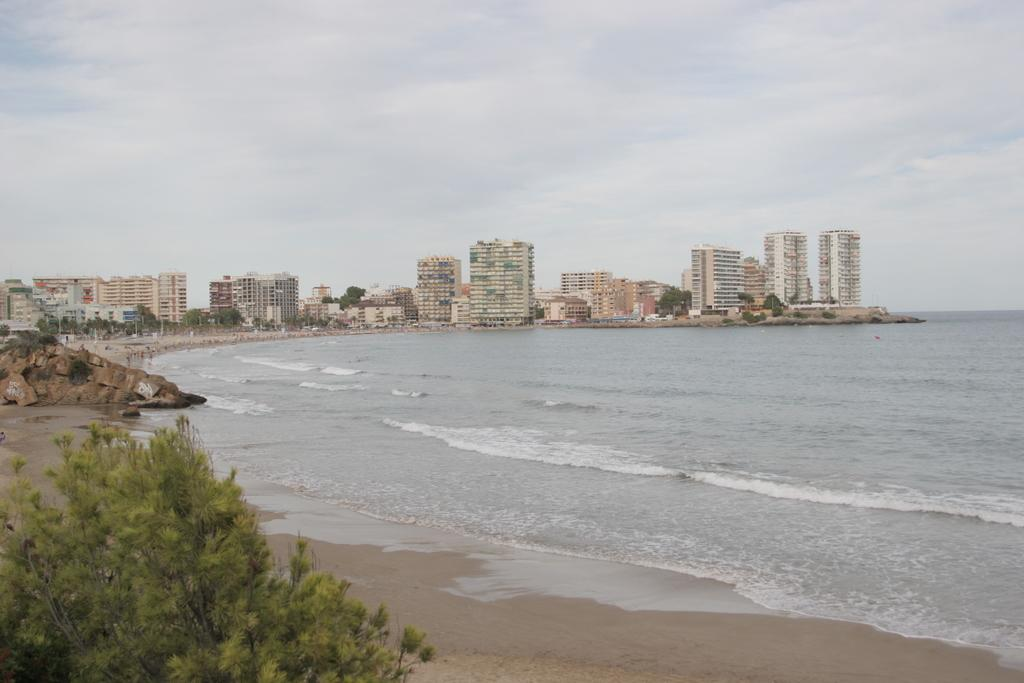What is located in the front of the image? There is a tree in the front of the image. What can be seen in the image besides the tree? Water is visible in the image. What is visible in the background of the image? There are trees and buildings in the background of the image. What is visible at the top of the image? The sky is visible at the top of the image. What type of thunder can be heard in the image? There is no thunder present in the image, as it is a visual representation and does not include sound. 